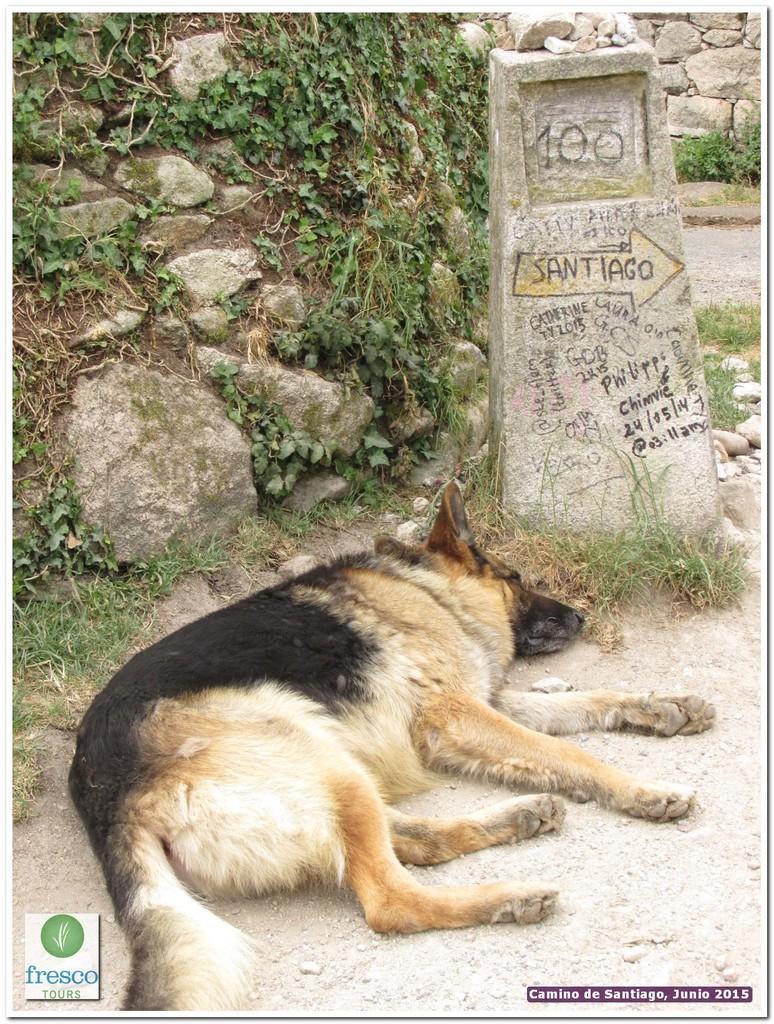Describe this image in one or two sentences. In this image we can see a dog. Also there is a stone pillar with text. On the ground there is grass. Also there are stones and few plants. In the back there is a stone wall. 